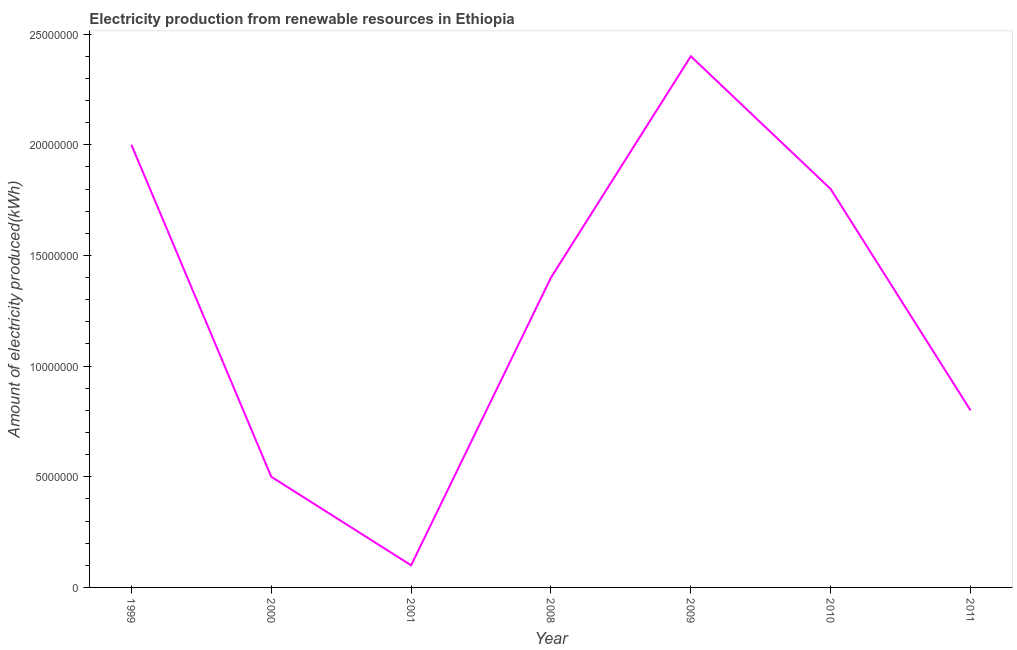What is the amount of electricity produced in 2010?
Your response must be concise. 1.80e+07. Across all years, what is the maximum amount of electricity produced?
Provide a succinct answer. 2.40e+07. Across all years, what is the minimum amount of electricity produced?
Provide a succinct answer. 1.00e+06. In which year was the amount of electricity produced maximum?
Give a very brief answer. 2009. What is the sum of the amount of electricity produced?
Ensure brevity in your answer.  9.00e+07. What is the difference between the amount of electricity produced in 2010 and 2011?
Keep it short and to the point. 1.00e+07. What is the average amount of electricity produced per year?
Make the answer very short. 1.29e+07. What is the median amount of electricity produced?
Your response must be concise. 1.40e+07. What is the ratio of the amount of electricity produced in 2010 to that in 2011?
Offer a terse response. 2.25. Is the amount of electricity produced in 1999 less than that in 2008?
Provide a succinct answer. No. What is the difference between the highest and the lowest amount of electricity produced?
Provide a short and direct response. 2.30e+07. Does the amount of electricity produced monotonically increase over the years?
Your response must be concise. No. Does the graph contain any zero values?
Your answer should be compact. No. What is the title of the graph?
Ensure brevity in your answer.  Electricity production from renewable resources in Ethiopia. What is the label or title of the X-axis?
Your response must be concise. Year. What is the label or title of the Y-axis?
Give a very brief answer. Amount of electricity produced(kWh). What is the Amount of electricity produced(kWh) of 1999?
Provide a succinct answer. 2.00e+07. What is the Amount of electricity produced(kWh) of 2000?
Offer a terse response. 5.00e+06. What is the Amount of electricity produced(kWh) of 2008?
Ensure brevity in your answer.  1.40e+07. What is the Amount of electricity produced(kWh) in 2009?
Keep it short and to the point. 2.40e+07. What is the Amount of electricity produced(kWh) in 2010?
Offer a terse response. 1.80e+07. What is the difference between the Amount of electricity produced(kWh) in 1999 and 2000?
Offer a terse response. 1.50e+07. What is the difference between the Amount of electricity produced(kWh) in 1999 and 2001?
Ensure brevity in your answer.  1.90e+07. What is the difference between the Amount of electricity produced(kWh) in 1999 and 2010?
Keep it short and to the point. 2.00e+06. What is the difference between the Amount of electricity produced(kWh) in 1999 and 2011?
Give a very brief answer. 1.20e+07. What is the difference between the Amount of electricity produced(kWh) in 2000 and 2001?
Ensure brevity in your answer.  4.00e+06. What is the difference between the Amount of electricity produced(kWh) in 2000 and 2008?
Your response must be concise. -9.00e+06. What is the difference between the Amount of electricity produced(kWh) in 2000 and 2009?
Ensure brevity in your answer.  -1.90e+07. What is the difference between the Amount of electricity produced(kWh) in 2000 and 2010?
Give a very brief answer. -1.30e+07. What is the difference between the Amount of electricity produced(kWh) in 2001 and 2008?
Your answer should be very brief. -1.30e+07. What is the difference between the Amount of electricity produced(kWh) in 2001 and 2009?
Make the answer very short. -2.30e+07. What is the difference between the Amount of electricity produced(kWh) in 2001 and 2010?
Make the answer very short. -1.70e+07. What is the difference between the Amount of electricity produced(kWh) in 2001 and 2011?
Your response must be concise. -7.00e+06. What is the difference between the Amount of electricity produced(kWh) in 2008 and 2009?
Ensure brevity in your answer.  -1.00e+07. What is the difference between the Amount of electricity produced(kWh) in 2009 and 2011?
Ensure brevity in your answer.  1.60e+07. What is the ratio of the Amount of electricity produced(kWh) in 1999 to that in 2000?
Offer a terse response. 4. What is the ratio of the Amount of electricity produced(kWh) in 1999 to that in 2001?
Provide a succinct answer. 20. What is the ratio of the Amount of electricity produced(kWh) in 1999 to that in 2008?
Your answer should be compact. 1.43. What is the ratio of the Amount of electricity produced(kWh) in 1999 to that in 2009?
Give a very brief answer. 0.83. What is the ratio of the Amount of electricity produced(kWh) in 1999 to that in 2010?
Provide a succinct answer. 1.11. What is the ratio of the Amount of electricity produced(kWh) in 2000 to that in 2008?
Your answer should be very brief. 0.36. What is the ratio of the Amount of electricity produced(kWh) in 2000 to that in 2009?
Your answer should be very brief. 0.21. What is the ratio of the Amount of electricity produced(kWh) in 2000 to that in 2010?
Provide a succinct answer. 0.28. What is the ratio of the Amount of electricity produced(kWh) in 2001 to that in 2008?
Your answer should be compact. 0.07. What is the ratio of the Amount of electricity produced(kWh) in 2001 to that in 2009?
Give a very brief answer. 0.04. What is the ratio of the Amount of electricity produced(kWh) in 2001 to that in 2010?
Offer a very short reply. 0.06. What is the ratio of the Amount of electricity produced(kWh) in 2001 to that in 2011?
Keep it short and to the point. 0.12. What is the ratio of the Amount of electricity produced(kWh) in 2008 to that in 2009?
Offer a very short reply. 0.58. What is the ratio of the Amount of electricity produced(kWh) in 2008 to that in 2010?
Make the answer very short. 0.78. What is the ratio of the Amount of electricity produced(kWh) in 2009 to that in 2010?
Offer a very short reply. 1.33. What is the ratio of the Amount of electricity produced(kWh) in 2009 to that in 2011?
Your answer should be compact. 3. What is the ratio of the Amount of electricity produced(kWh) in 2010 to that in 2011?
Ensure brevity in your answer.  2.25. 